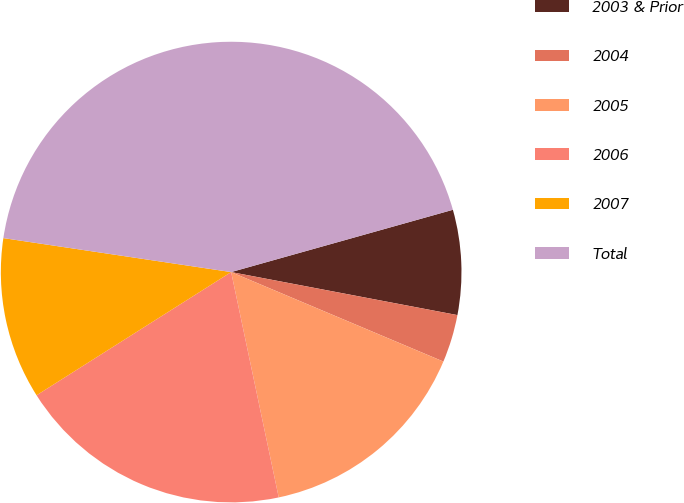Convert chart. <chart><loc_0><loc_0><loc_500><loc_500><pie_chart><fcel>2003 & Prior<fcel>2004<fcel>2005<fcel>2006<fcel>2007<fcel>Total<nl><fcel>7.35%<fcel>3.36%<fcel>15.34%<fcel>19.33%<fcel>11.34%<fcel>43.29%<nl></chart> 